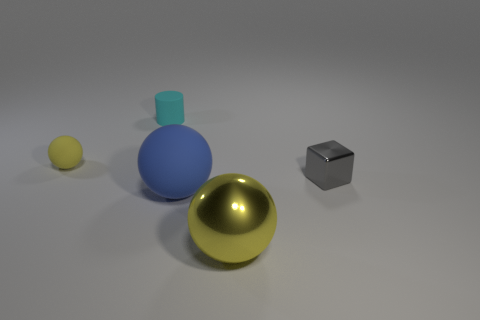Subtract all yellow blocks. Subtract all yellow balls. How many blocks are left? 1 Add 3 tiny rubber things. How many objects exist? 8 Subtract all blocks. How many objects are left? 4 Add 5 big shiny objects. How many big shiny objects are left? 6 Add 5 small red shiny cylinders. How many small red shiny cylinders exist? 5 Subtract 0 gray balls. How many objects are left? 5 Subtract all large metallic objects. Subtract all yellow matte things. How many objects are left? 3 